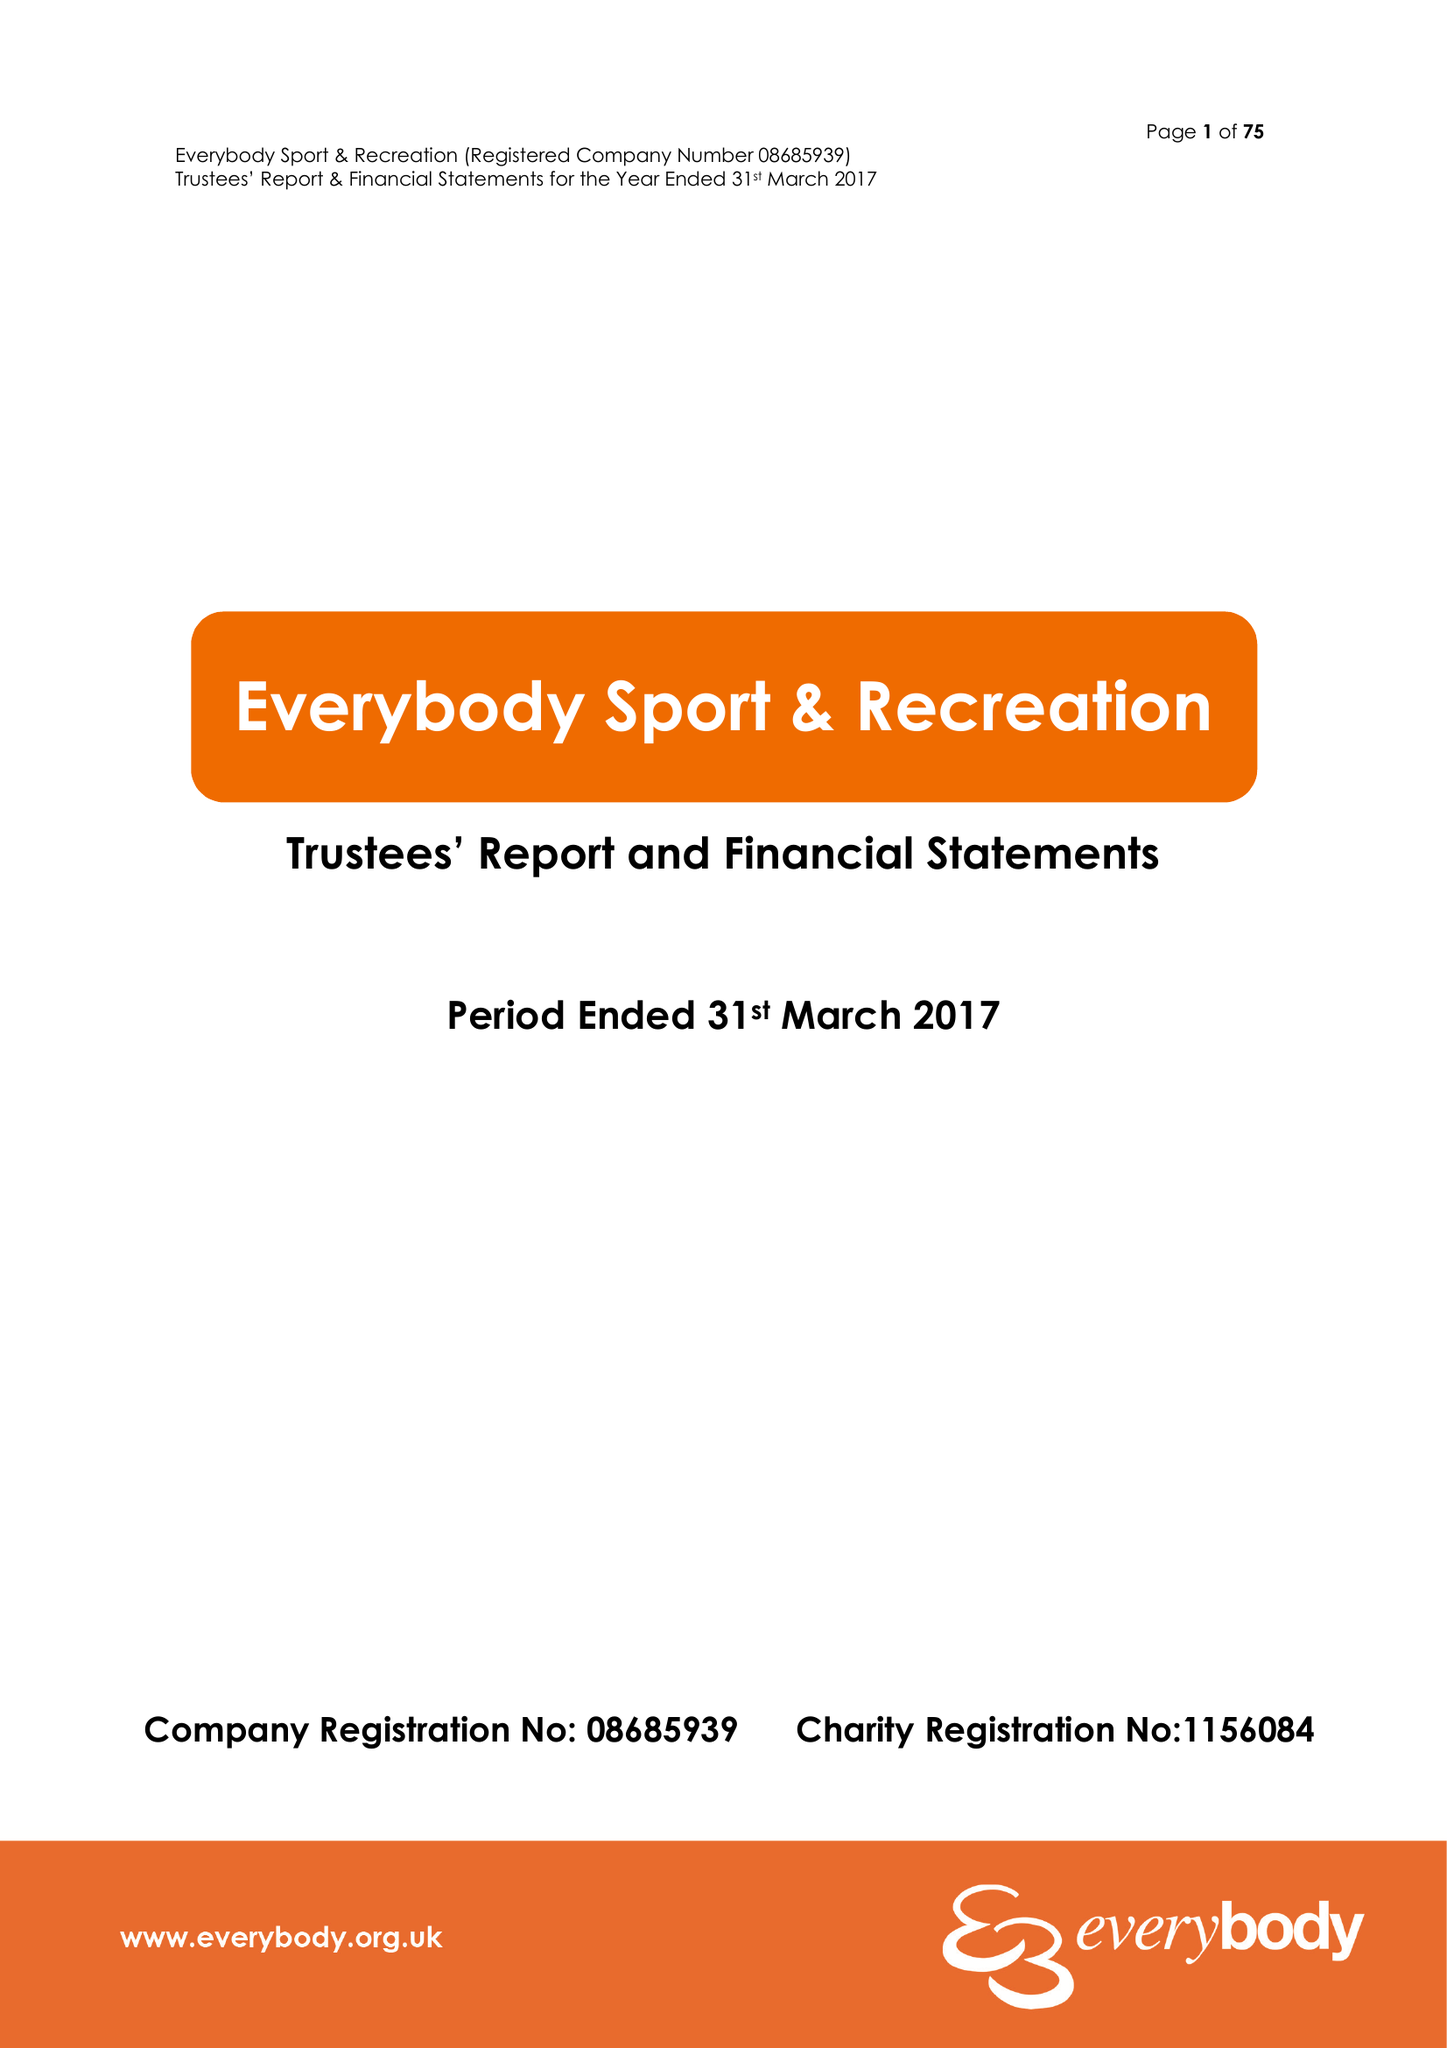What is the value for the address__postcode?
Answer the question using a single word or phrase. CW4 8AA 